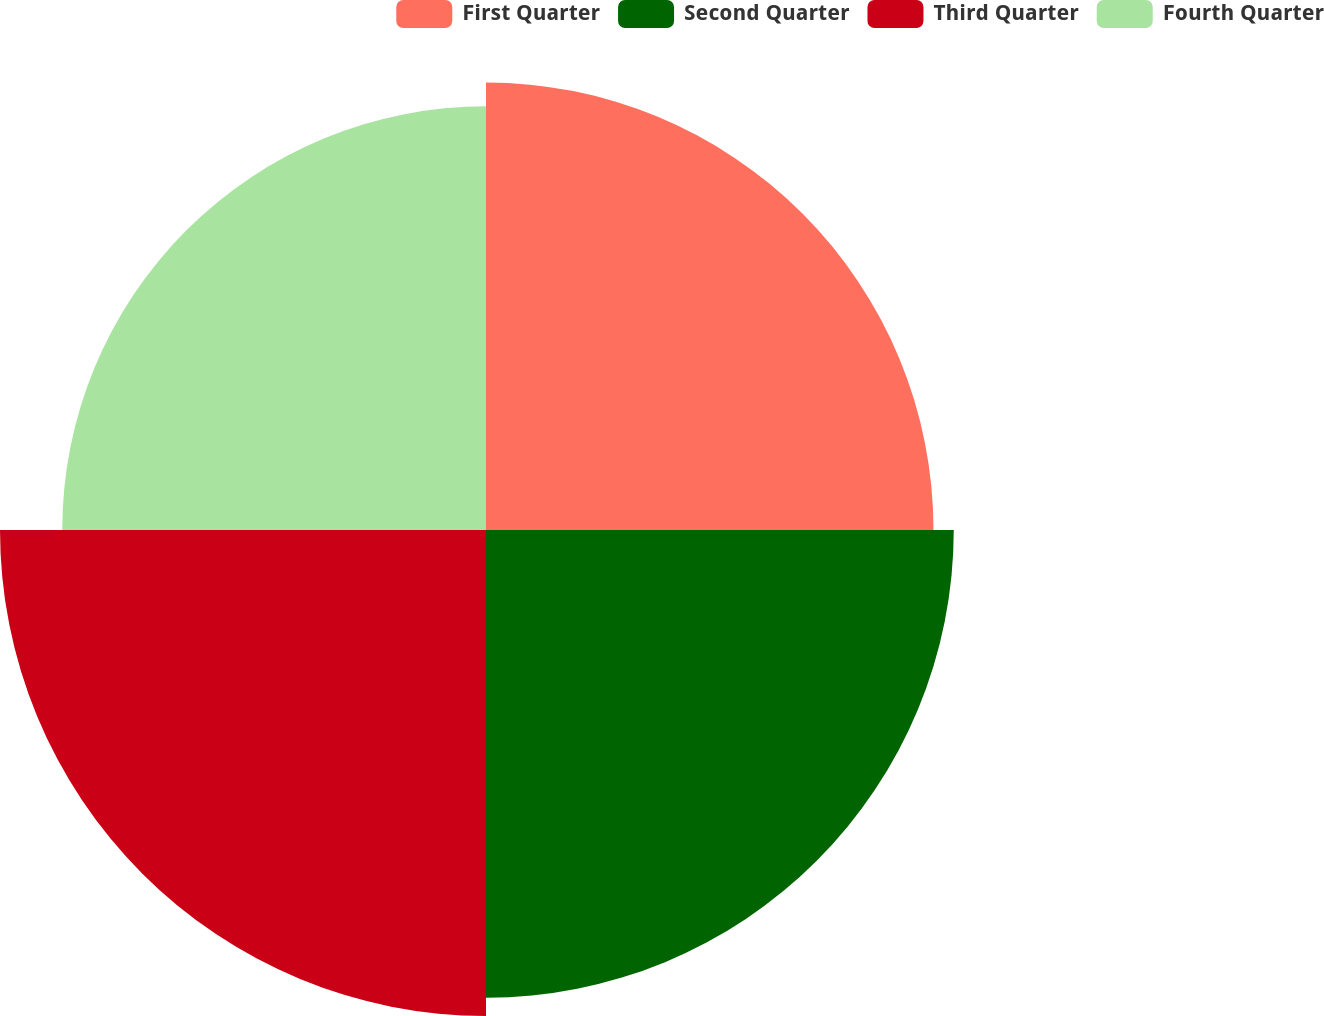<chart> <loc_0><loc_0><loc_500><loc_500><pie_chart><fcel>First Quarter<fcel>Second Quarter<fcel>Third Quarter<fcel>Fourth Quarter<nl><fcel>24.52%<fcel>25.63%<fcel>26.63%<fcel>23.22%<nl></chart> 